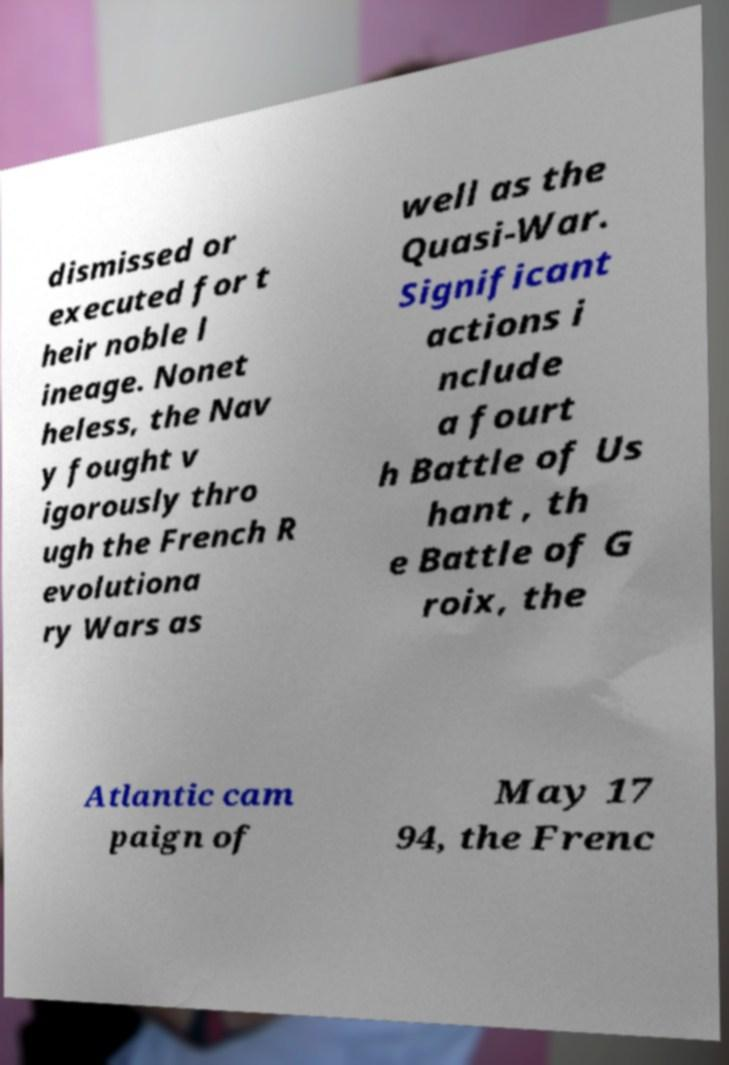Can you read and provide the text displayed in the image?This photo seems to have some interesting text. Can you extract and type it out for me? dismissed or executed for t heir noble l ineage. Nonet heless, the Nav y fought v igorously thro ugh the French R evolutiona ry Wars as well as the Quasi-War. Significant actions i nclude a fourt h Battle of Us hant , th e Battle of G roix, the Atlantic cam paign of May 17 94, the Frenc 